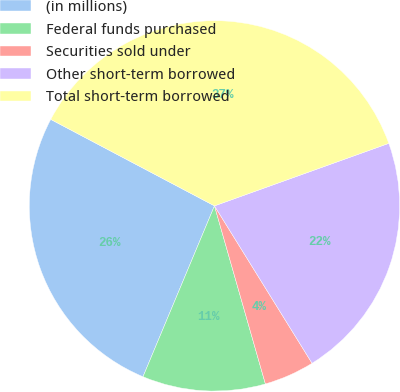Convert chart to OTSL. <chart><loc_0><loc_0><loc_500><loc_500><pie_chart><fcel>(in millions)<fcel>Federal funds purchased<fcel>Securities sold under<fcel>Other short-term borrowed<fcel>Total short-term borrowed<nl><fcel>26.43%<fcel>10.74%<fcel>4.4%<fcel>21.65%<fcel>36.79%<nl></chart> 